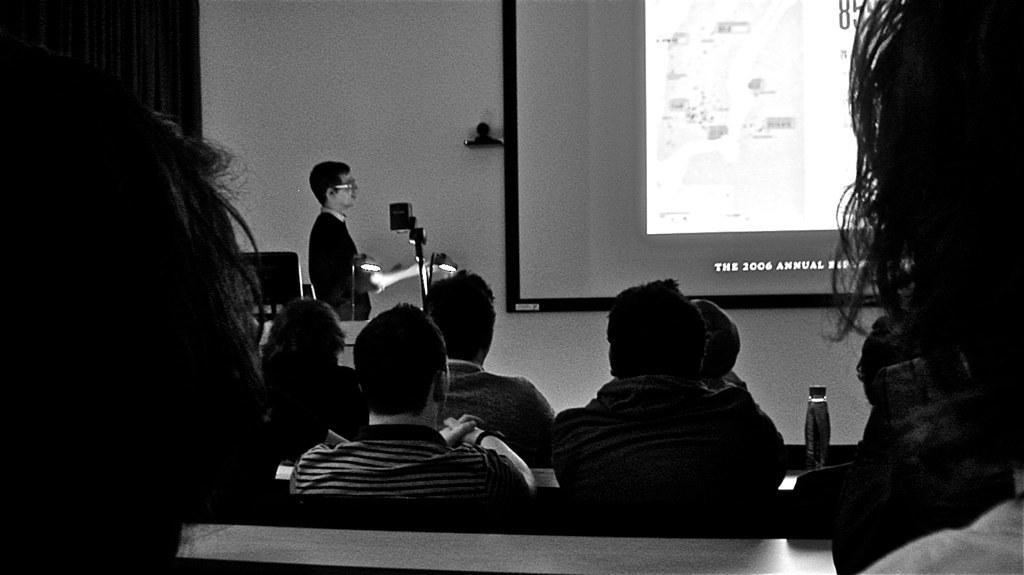Can you describe this image briefly? This is a seminar hall with a person standing on the left side wearing a black t-shirt and spectacles. There is a bottle on the right side of the table. There are people sitting on bench in the foreground and there is a presentation At the background. 